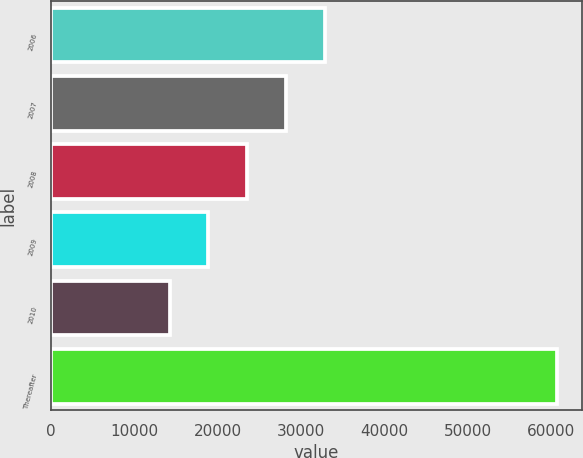<chart> <loc_0><loc_0><loc_500><loc_500><bar_chart><fcel>2006<fcel>2007<fcel>2008<fcel>2009<fcel>2010<fcel>Thereafter<nl><fcel>32796.4<fcel>28153.8<fcel>23511.2<fcel>18868.6<fcel>14226<fcel>60652<nl></chart> 